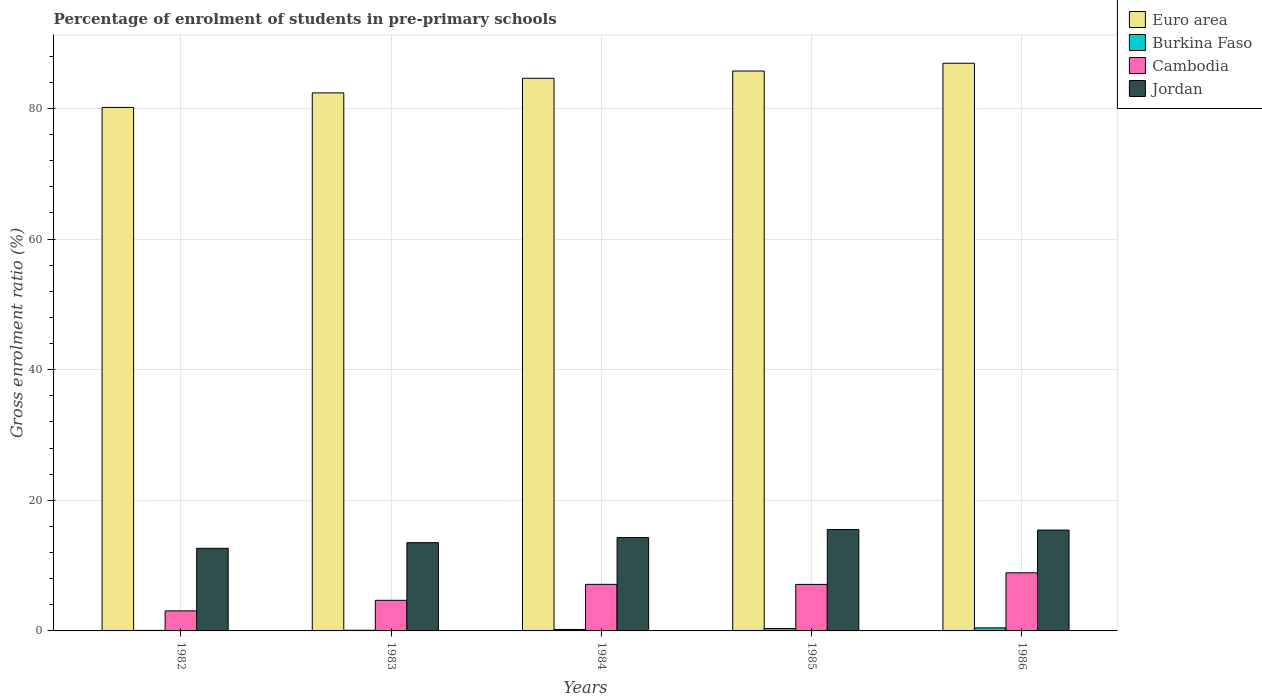Are the number of bars per tick equal to the number of legend labels?
Your answer should be very brief. Yes. How many bars are there on the 2nd tick from the right?
Ensure brevity in your answer.  4. What is the label of the 2nd group of bars from the left?
Offer a terse response. 1983. In how many cases, is the number of bars for a given year not equal to the number of legend labels?
Make the answer very short. 0. What is the percentage of students enrolled in pre-primary schools in Jordan in 1986?
Give a very brief answer. 15.44. Across all years, what is the maximum percentage of students enrolled in pre-primary schools in Cambodia?
Give a very brief answer. 8.9. Across all years, what is the minimum percentage of students enrolled in pre-primary schools in Burkina Faso?
Offer a very short reply. 0.08. In which year was the percentage of students enrolled in pre-primary schools in Cambodia maximum?
Offer a very short reply. 1986. What is the total percentage of students enrolled in pre-primary schools in Cambodia in the graph?
Your response must be concise. 30.91. What is the difference between the percentage of students enrolled in pre-primary schools in Euro area in 1984 and that in 1985?
Your answer should be compact. -1.11. What is the difference between the percentage of students enrolled in pre-primary schools in Euro area in 1986 and the percentage of students enrolled in pre-primary schools in Burkina Faso in 1983?
Give a very brief answer. 86.81. What is the average percentage of students enrolled in pre-primary schools in Euro area per year?
Give a very brief answer. 83.95. In the year 1985, what is the difference between the percentage of students enrolled in pre-primary schools in Burkina Faso and percentage of students enrolled in pre-primary schools in Euro area?
Offer a terse response. -85.36. What is the ratio of the percentage of students enrolled in pre-primary schools in Cambodia in 1983 to that in 1985?
Ensure brevity in your answer.  0.66. Is the difference between the percentage of students enrolled in pre-primary schools in Burkina Faso in 1985 and 1986 greater than the difference between the percentage of students enrolled in pre-primary schools in Euro area in 1985 and 1986?
Provide a short and direct response. Yes. What is the difference between the highest and the second highest percentage of students enrolled in pre-primary schools in Jordan?
Your answer should be very brief. 0.09. What is the difference between the highest and the lowest percentage of students enrolled in pre-primary schools in Euro area?
Offer a very short reply. 6.76. In how many years, is the percentage of students enrolled in pre-primary schools in Burkina Faso greater than the average percentage of students enrolled in pre-primary schools in Burkina Faso taken over all years?
Offer a terse response. 2. Is the sum of the percentage of students enrolled in pre-primary schools in Burkina Faso in 1983 and 1986 greater than the maximum percentage of students enrolled in pre-primary schools in Cambodia across all years?
Offer a very short reply. No. Is it the case that in every year, the sum of the percentage of students enrolled in pre-primary schools in Cambodia and percentage of students enrolled in pre-primary schools in Burkina Faso is greater than the sum of percentage of students enrolled in pre-primary schools in Euro area and percentage of students enrolled in pre-primary schools in Jordan?
Your answer should be compact. No. What does the 2nd bar from the left in 1985 represents?
Your answer should be very brief. Burkina Faso. What does the 4th bar from the right in 1984 represents?
Make the answer very short. Euro area. Is it the case that in every year, the sum of the percentage of students enrolled in pre-primary schools in Jordan and percentage of students enrolled in pre-primary schools in Euro area is greater than the percentage of students enrolled in pre-primary schools in Burkina Faso?
Offer a terse response. Yes. How many bars are there?
Keep it short and to the point. 20. Are the values on the major ticks of Y-axis written in scientific E-notation?
Provide a short and direct response. No. Where does the legend appear in the graph?
Ensure brevity in your answer.  Top right. What is the title of the graph?
Ensure brevity in your answer.  Percentage of enrolment of students in pre-primary schools. Does "North America" appear as one of the legend labels in the graph?
Your answer should be compact. No. What is the label or title of the Y-axis?
Keep it short and to the point. Gross enrolment ratio (%). What is the Gross enrolment ratio (%) in Euro area in 1982?
Offer a very short reply. 80.15. What is the Gross enrolment ratio (%) in Burkina Faso in 1982?
Provide a succinct answer. 0.08. What is the Gross enrolment ratio (%) of Cambodia in 1982?
Your answer should be compact. 3.07. What is the Gross enrolment ratio (%) of Jordan in 1982?
Give a very brief answer. 12.65. What is the Gross enrolment ratio (%) of Euro area in 1983?
Provide a short and direct response. 82.37. What is the Gross enrolment ratio (%) of Burkina Faso in 1983?
Offer a very short reply. 0.1. What is the Gross enrolment ratio (%) in Cambodia in 1983?
Keep it short and to the point. 4.69. What is the Gross enrolment ratio (%) in Jordan in 1983?
Give a very brief answer. 13.51. What is the Gross enrolment ratio (%) of Euro area in 1984?
Provide a succinct answer. 84.61. What is the Gross enrolment ratio (%) of Burkina Faso in 1984?
Give a very brief answer. 0.23. What is the Gross enrolment ratio (%) of Cambodia in 1984?
Offer a very short reply. 7.13. What is the Gross enrolment ratio (%) in Jordan in 1984?
Keep it short and to the point. 14.29. What is the Gross enrolment ratio (%) of Euro area in 1985?
Provide a succinct answer. 85.72. What is the Gross enrolment ratio (%) of Burkina Faso in 1985?
Ensure brevity in your answer.  0.36. What is the Gross enrolment ratio (%) of Cambodia in 1985?
Keep it short and to the point. 7.12. What is the Gross enrolment ratio (%) in Jordan in 1985?
Provide a short and direct response. 15.53. What is the Gross enrolment ratio (%) in Euro area in 1986?
Provide a short and direct response. 86.91. What is the Gross enrolment ratio (%) in Burkina Faso in 1986?
Make the answer very short. 0.46. What is the Gross enrolment ratio (%) of Cambodia in 1986?
Keep it short and to the point. 8.9. What is the Gross enrolment ratio (%) of Jordan in 1986?
Provide a succinct answer. 15.44. Across all years, what is the maximum Gross enrolment ratio (%) in Euro area?
Provide a short and direct response. 86.91. Across all years, what is the maximum Gross enrolment ratio (%) of Burkina Faso?
Your answer should be very brief. 0.46. Across all years, what is the maximum Gross enrolment ratio (%) in Cambodia?
Offer a very short reply. 8.9. Across all years, what is the maximum Gross enrolment ratio (%) in Jordan?
Ensure brevity in your answer.  15.53. Across all years, what is the minimum Gross enrolment ratio (%) of Euro area?
Your answer should be compact. 80.15. Across all years, what is the minimum Gross enrolment ratio (%) in Burkina Faso?
Offer a terse response. 0.08. Across all years, what is the minimum Gross enrolment ratio (%) in Cambodia?
Make the answer very short. 3.07. Across all years, what is the minimum Gross enrolment ratio (%) in Jordan?
Ensure brevity in your answer.  12.65. What is the total Gross enrolment ratio (%) of Euro area in the graph?
Ensure brevity in your answer.  419.77. What is the total Gross enrolment ratio (%) in Burkina Faso in the graph?
Give a very brief answer. 1.24. What is the total Gross enrolment ratio (%) of Cambodia in the graph?
Make the answer very short. 30.91. What is the total Gross enrolment ratio (%) in Jordan in the graph?
Provide a succinct answer. 71.42. What is the difference between the Gross enrolment ratio (%) of Euro area in 1982 and that in 1983?
Ensure brevity in your answer.  -2.23. What is the difference between the Gross enrolment ratio (%) of Burkina Faso in 1982 and that in 1983?
Offer a very short reply. -0.02. What is the difference between the Gross enrolment ratio (%) in Cambodia in 1982 and that in 1983?
Provide a short and direct response. -1.61. What is the difference between the Gross enrolment ratio (%) of Jordan in 1982 and that in 1983?
Offer a very short reply. -0.87. What is the difference between the Gross enrolment ratio (%) in Euro area in 1982 and that in 1984?
Offer a terse response. -4.47. What is the difference between the Gross enrolment ratio (%) of Burkina Faso in 1982 and that in 1984?
Provide a short and direct response. -0.14. What is the difference between the Gross enrolment ratio (%) in Cambodia in 1982 and that in 1984?
Ensure brevity in your answer.  -4.06. What is the difference between the Gross enrolment ratio (%) in Jordan in 1982 and that in 1984?
Offer a terse response. -1.64. What is the difference between the Gross enrolment ratio (%) in Euro area in 1982 and that in 1985?
Make the answer very short. -5.58. What is the difference between the Gross enrolment ratio (%) in Burkina Faso in 1982 and that in 1985?
Give a very brief answer. -0.28. What is the difference between the Gross enrolment ratio (%) in Cambodia in 1982 and that in 1985?
Make the answer very short. -4.05. What is the difference between the Gross enrolment ratio (%) of Jordan in 1982 and that in 1985?
Offer a very short reply. -2.88. What is the difference between the Gross enrolment ratio (%) in Euro area in 1982 and that in 1986?
Provide a short and direct response. -6.76. What is the difference between the Gross enrolment ratio (%) of Burkina Faso in 1982 and that in 1986?
Provide a succinct answer. -0.38. What is the difference between the Gross enrolment ratio (%) in Cambodia in 1982 and that in 1986?
Provide a short and direct response. -5.83. What is the difference between the Gross enrolment ratio (%) of Jordan in 1982 and that in 1986?
Make the answer very short. -2.79. What is the difference between the Gross enrolment ratio (%) in Euro area in 1983 and that in 1984?
Offer a very short reply. -2.24. What is the difference between the Gross enrolment ratio (%) of Burkina Faso in 1983 and that in 1984?
Ensure brevity in your answer.  -0.13. What is the difference between the Gross enrolment ratio (%) in Cambodia in 1983 and that in 1984?
Provide a short and direct response. -2.44. What is the difference between the Gross enrolment ratio (%) of Jordan in 1983 and that in 1984?
Ensure brevity in your answer.  -0.78. What is the difference between the Gross enrolment ratio (%) in Euro area in 1983 and that in 1985?
Make the answer very short. -3.35. What is the difference between the Gross enrolment ratio (%) of Burkina Faso in 1983 and that in 1985?
Give a very brief answer. -0.26. What is the difference between the Gross enrolment ratio (%) of Cambodia in 1983 and that in 1985?
Your answer should be very brief. -2.44. What is the difference between the Gross enrolment ratio (%) of Jordan in 1983 and that in 1985?
Provide a succinct answer. -2.01. What is the difference between the Gross enrolment ratio (%) in Euro area in 1983 and that in 1986?
Your answer should be very brief. -4.54. What is the difference between the Gross enrolment ratio (%) in Burkina Faso in 1983 and that in 1986?
Your answer should be very brief. -0.36. What is the difference between the Gross enrolment ratio (%) in Cambodia in 1983 and that in 1986?
Make the answer very short. -4.21. What is the difference between the Gross enrolment ratio (%) in Jordan in 1983 and that in 1986?
Your answer should be very brief. -1.93. What is the difference between the Gross enrolment ratio (%) of Euro area in 1984 and that in 1985?
Give a very brief answer. -1.11. What is the difference between the Gross enrolment ratio (%) in Burkina Faso in 1984 and that in 1985?
Offer a very short reply. -0.14. What is the difference between the Gross enrolment ratio (%) in Cambodia in 1984 and that in 1985?
Offer a very short reply. 0.01. What is the difference between the Gross enrolment ratio (%) in Jordan in 1984 and that in 1985?
Offer a terse response. -1.24. What is the difference between the Gross enrolment ratio (%) of Euro area in 1984 and that in 1986?
Offer a terse response. -2.3. What is the difference between the Gross enrolment ratio (%) in Burkina Faso in 1984 and that in 1986?
Offer a terse response. -0.24. What is the difference between the Gross enrolment ratio (%) in Cambodia in 1984 and that in 1986?
Your answer should be very brief. -1.77. What is the difference between the Gross enrolment ratio (%) of Jordan in 1984 and that in 1986?
Offer a very short reply. -1.15. What is the difference between the Gross enrolment ratio (%) of Euro area in 1985 and that in 1986?
Your response must be concise. -1.19. What is the difference between the Gross enrolment ratio (%) of Burkina Faso in 1985 and that in 1986?
Provide a succinct answer. -0.1. What is the difference between the Gross enrolment ratio (%) of Cambodia in 1985 and that in 1986?
Keep it short and to the point. -1.78. What is the difference between the Gross enrolment ratio (%) of Jordan in 1985 and that in 1986?
Your response must be concise. 0.09. What is the difference between the Gross enrolment ratio (%) of Euro area in 1982 and the Gross enrolment ratio (%) of Burkina Faso in 1983?
Make the answer very short. 80.05. What is the difference between the Gross enrolment ratio (%) in Euro area in 1982 and the Gross enrolment ratio (%) in Cambodia in 1983?
Make the answer very short. 75.46. What is the difference between the Gross enrolment ratio (%) of Euro area in 1982 and the Gross enrolment ratio (%) of Jordan in 1983?
Offer a terse response. 66.63. What is the difference between the Gross enrolment ratio (%) in Burkina Faso in 1982 and the Gross enrolment ratio (%) in Cambodia in 1983?
Ensure brevity in your answer.  -4.6. What is the difference between the Gross enrolment ratio (%) of Burkina Faso in 1982 and the Gross enrolment ratio (%) of Jordan in 1983?
Your answer should be compact. -13.43. What is the difference between the Gross enrolment ratio (%) in Cambodia in 1982 and the Gross enrolment ratio (%) in Jordan in 1983?
Offer a very short reply. -10.44. What is the difference between the Gross enrolment ratio (%) in Euro area in 1982 and the Gross enrolment ratio (%) in Burkina Faso in 1984?
Offer a terse response. 79.92. What is the difference between the Gross enrolment ratio (%) of Euro area in 1982 and the Gross enrolment ratio (%) of Cambodia in 1984?
Give a very brief answer. 73.02. What is the difference between the Gross enrolment ratio (%) of Euro area in 1982 and the Gross enrolment ratio (%) of Jordan in 1984?
Provide a succinct answer. 65.86. What is the difference between the Gross enrolment ratio (%) of Burkina Faso in 1982 and the Gross enrolment ratio (%) of Cambodia in 1984?
Provide a short and direct response. -7.05. What is the difference between the Gross enrolment ratio (%) in Burkina Faso in 1982 and the Gross enrolment ratio (%) in Jordan in 1984?
Offer a very short reply. -14.21. What is the difference between the Gross enrolment ratio (%) of Cambodia in 1982 and the Gross enrolment ratio (%) of Jordan in 1984?
Your answer should be very brief. -11.22. What is the difference between the Gross enrolment ratio (%) of Euro area in 1982 and the Gross enrolment ratio (%) of Burkina Faso in 1985?
Keep it short and to the point. 79.78. What is the difference between the Gross enrolment ratio (%) in Euro area in 1982 and the Gross enrolment ratio (%) in Cambodia in 1985?
Offer a very short reply. 73.03. What is the difference between the Gross enrolment ratio (%) of Euro area in 1982 and the Gross enrolment ratio (%) of Jordan in 1985?
Your response must be concise. 64.62. What is the difference between the Gross enrolment ratio (%) in Burkina Faso in 1982 and the Gross enrolment ratio (%) in Cambodia in 1985?
Ensure brevity in your answer.  -7.04. What is the difference between the Gross enrolment ratio (%) in Burkina Faso in 1982 and the Gross enrolment ratio (%) in Jordan in 1985?
Provide a short and direct response. -15.44. What is the difference between the Gross enrolment ratio (%) of Cambodia in 1982 and the Gross enrolment ratio (%) of Jordan in 1985?
Make the answer very short. -12.45. What is the difference between the Gross enrolment ratio (%) of Euro area in 1982 and the Gross enrolment ratio (%) of Burkina Faso in 1986?
Your response must be concise. 79.68. What is the difference between the Gross enrolment ratio (%) of Euro area in 1982 and the Gross enrolment ratio (%) of Cambodia in 1986?
Provide a succinct answer. 71.25. What is the difference between the Gross enrolment ratio (%) in Euro area in 1982 and the Gross enrolment ratio (%) in Jordan in 1986?
Your response must be concise. 64.71. What is the difference between the Gross enrolment ratio (%) in Burkina Faso in 1982 and the Gross enrolment ratio (%) in Cambodia in 1986?
Make the answer very short. -8.82. What is the difference between the Gross enrolment ratio (%) in Burkina Faso in 1982 and the Gross enrolment ratio (%) in Jordan in 1986?
Offer a very short reply. -15.36. What is the difference between the Gross enrolment ratio (%) in Cambodia in 1982 and the Gross enrolment ratio (%) in Jordan in 1986?
Your answer should be compact. -12.37. What is the difference between the Gross enrolment ratio (%) in Euro area in 1983 and the Gross enrolment ratio (%) in Burkina Faso in 1984?
Your answer should be very brief. 82.15. What is the difference between the Gross enrolment ratio (%) in Euro area in 1983 and the Gross enrolment ratio (%) in Cambodia in 1984?
Make the answer very short. 75.24. What is the difference between the Gross enrolment ratio (%) of Euro area in 1983 and the Gross enrolment ratio (%) of Jordan in 1984?
Provide a succinct answer. 68.08. What is the difference between the Gross enrolment ratio (%) in Burkina Faso in 1983 and the Gross enrolment ratio (%) in Cambodia in 1984?
Make the answer very short. -7.03. What is the difference between the Gross enrolment ratio (%) of Burkina Faso in 1983 and the Gross enrolment ratio (%) of Jordan in 1984?
Your answer should be compact. -14.19. What is the difference between the Gross enrolment ratio (%) of Cambodia in 1983 and the Gross enrolment ratio (%) of Jordan in 1984?
Keep it short and to the point. -9.6. What is the difference between the Gross enrolment ratio (%) in Euro area in 1983 and the Gross enrolment ratio (%) in Burkina Faso in 1985?
Provide a succinct answer. 82.01. What is the difference between the Gross enrolment ratio (%) of Euro area in 1983 and the Gross enrolment ratio (%) of Cambodia in 1985?
Make the answer very short. 75.25. What is the difference between the Gross enrolment ratio (%) in Euro area in 1983 and the Gross enrolment ratio (%) in Jordan in 1985?
Offer a very short reply. 66.85. What is the difference between the Gross enrolment ratio (%) in Burkina Faso in 1983 and the Gross enrolment ratio (%) in Cambodia in 1985?
Offer a very short reply. -7.02. What is the difference between the Gross enrolment ratio (%) of Burkina Faso in 1983 and the Gross enrolment ratio (%) of Jordan in 1985?
Keep it short and to the point. -15.43. What is the difference between the Gross enrolment ratio (%) of Cambodia in 1983 and the Gross enrolment ratio (%) of Jordan in 1985?
Provide a succinct answer. -10.84. What is the difference between the Gross enrolment ratio (%) of Euro area in 1983 and the Gross enrolment ratio (%) of Burkina Faso in 1986?
Give a very brief answer. 81.91. What is the difference between the Gross enrolment ratio (%) in Euro area in 1983 and the Gross enrolment ratio (%) in Cambodia in 1986?
Offer a terse response. 73.48. What is the difference between the Gross enrolment ratio (%) in Euro area in 1983 and the Gross enrolment ratio (%) in Jordan in 1986?
Provide a succinct answer. 66.93. What is the difference between the Gross enrolment ratio (%) of Burkina Faso in 1983 and the Gross enrolment ratio (%) of Cambodia in 1986?
Provide a short and direct response. -8.8. What is the difference between the Gross enrolment ratio (%) of Burkina Faso in 1983 and the Gross enrolment ratio (%) of Jordan in 1986?
Your response must be concise. -15.34. What is the difference between the Gross enrolment ratio (%) of Cambodia in 1983 and the Gross enrolment ratio (%) of Jordan in 1986?
Provide a succinct answer. -10.75. What is the difference between the Gross enrolment ratio (%) in Euro area in 1984 and the Gross enrolment ratio (%) in Burkina Faso in 1985?
Your response must be concise. 84.25. What is the difference between the Gross enrolment ratio (%) in Euro area in 1984 and the Gross enrolment ratio (%) in Cambodia in 1985?
Provide a succinct answer. 77.49. What is the difference between the Gross enrolment ratio (%) of Euro area in 1984 and the Gross enrolment ratio (%) of Jordan in 1985?
Your answer should be compact. 69.09. What is the difference between the Gross enrolment ratio (%) in Burkina Faso in 1984 and the Gross enrolment ratio (%) in Cambodia in 1985?
Provide a succinct answer. -6.89. What is the difference between the Gross enrolment ratio (%) in Burkina Faso in 1984 and the Gross enrolment ratio (%) in Jordan in 1985?
Provide a short and direct response. -15.3. What is the difference between the Gross enrolment ratio (%) in Cambodia in 1984 and the Gross enrolment ratio (%) in Jordan in 1985?
Offer a very short reply. -8.4. What is the difference between the Gross enrolment ratio (%) of Euro area in 1984 and the Gross enrolment ratio (%) of Burkina Faso in 1986?
Make the answer very short. 84.15. What is the difference between the Gross enrolment ratio (%) of Euro area in 1984 and the Gross enrolment ratio (%) of Cambodia in 1986?
Keep it short and to the point. 75.71. What is the difference between the Gross enrolment ratio (%) of Euro area in 1984 and the Gross enrolment ratio (%) of Jordan in 1986?
Make the answer very short. 69.17. What is the difference between the Gross enrolment ratio (%) of Burkina Faso in 1984 and the Gross enrolment ratio (%) of Cambodia in 1986?
Your answer should be compact. -8.67. What is the difference between the Gross enrolment ratio (%) of Burkina Faso in 1984 and the Gross enrolment ratio (%) of Jordan in 1986?
Make the answer very short. -15.21. What is the difference between the Gross enrolment ratio (%) of Cambodia in 1984 and the Gross enrolment ratio (%) of Jordan in 1986?
Your response must be concise. -8.31. What is the difference between the Gross enrolment ratio (%) in Euro area in 1985 and the Gross enrolment ratio (%) in Burkina Faso in 1986?
Your answer should be very brief. 85.26. What is the difference between the Gross enrolment ratio (%) in Euro area in 1985 and the Gross enrolment ratio (%) in Cambodia in 1986?
Provide a short and direct response. 76.82. What is the difference between the Gross enrolment ratio (%) of Euro area in 1985 and the Gross enrolment ratio (%) of Jordan in 1986?
Make the answer very short. 70.28. What is the difference between the Gross enrolment ratio (%) in Burkina Faso in 1985 and the Gross enrolment ratio (%) in Cambodia in 1986?
Give a very brief answer. -8.53. What is the difference between the Gross enrolment ratio (%) in Burkina Faso in 1985 and the Gross enrolment ratio (%) in Jordan in 1986?
Your response must be concise. -15.08. What is the difference between the Gross enrolment ratio (%) of Cambodia in 1985 and the Gross enrolment ratio (%) of Jordan in 1986?
Your response must be concise. -8.32. What is the average Gross enrolment ratio (%) of Euro area per year?
Your answer should be very brief. 83.95. What is the average Gross enrolment ratio (%) of Burkina Faso per year?
Provide a succinct answer. 0.25. What is the average Gross enrolment ratio (%) of Cambodia per year?
Your response must be concise. 6.18. What is the average Gross enrolment ratio (%) in Jordan per year?
Keep it short and to the point. 14.28. In the year 1982, what is the difference between the Gross enrolment ratio (%) in Euro area and Gross enrolment ratio (%) in Burkina Faso?
Ensure brevity in your answer.  80.07. In the year 1982, what is the difference between the Gross enrolment ratio (%) of Euro area and Gross enrolment ratio (%) of Cambodia?
Your answer should be very brief. 77.08. In the year 1982, what is the difference between the Gross enrolment ratio (%) of Euro area and Gross enrolment ratio (%) of Jordan?
Offer a terse response. 67.5. In the year 1982, what is the difference between the Gross enrolment ratio (%) of Burkina Faso and Gross enrolment ratio (%) of Cambodia?
Your answer should be very brief. -2.99. In the year 1982, what is the difference between the Gross enrolment ratio (%) of Burkina Faso and Gross enrolment ratio (%) of Jordan?
Make the answer very short. -12.57. In the year 1982, what is the difference between the Gross enrolment ratio (%) in Cambodia and Gross enrolment ratio (%) in Jordan?
Keep it short and to the point. -9.58. In the year 1983, what is the difference between the Gross enrolment ratio (%) of Euro area and Gross enrolment ratio (%) of Burkina Faso?
Provide a succinct answer. 82.27. In the year 1983, what is the difference between the Gross enrolment ratio (%) in Euro area and Gross enrolment ratio (%) in Cambodia?
Offer a very short reply. 77.69. In the year 1983, what is the difference between the Gross enrolment ratio (%) of Euro area and Gross enrolment ratio (%) of Jordan?
Offer a very short reply. 68.86. In the year 1983, what is the difference between the Gross enrolment ratio (%) of Burkina Faso and Gross enrolment ratio (%) of Cambodia?
Make the answer very short. -4.59. In the year 1983, what is the difference between the Gross enrolment ratio (%) of Burkina Faso and Gross enrolment ratio (%) of Jordan?
Provide a short and direct response. -13.41. In the year 1983, what is the difference between the Gross enrolment ratio (%) of Cambodia and Gross enrolment ratio (%) of Jordan?
Provide a succinct answer. -8.83. In the year 1984, what is the difference between the Gross enrolment ratio (%) in Euro area and Gross enrolment ratio (%) in Burkina Faso?
Provide a succinct answer. 84.39. In the year 1984, what is the difference between the Gross enrolment ratio (%) of Euro area and Gross enrolment ratio (%) of Cambodia?
Offer a terse response. 77.48. In the year 1984, what is the difference between the Gross enrolment ratio (%) of Euro area and Gross enrolment ratio (%) of Jordan?
Your answer should be compact. 70.32. In the year 1984, what is the difference between the Gross enrolment ratio (%) of Burkina Faso and Gross enrolment ratio (%) of Cambodia?
Offer a very short reply. -6.9. In the year 1984, what is the difference between the Gross enrolment ratio (%) in Burkina Faso and Gross enrolment ratio (%) in Jordan?
Offer a very short reply. -14.06. In the year 1984, what is the difference between the Gross enrolment ratio (%) of Cambodia and Gross enrolment ratio (%) of Jordan?
Your answer should be very brief. -7.16. In the year 1985, what is the difference between the Gross enrolment ratio (%) in Euro area and Gross enrolment ratio (%) in Burkina Faso?
Provide a succinct answer. 85.36. In the year 1985, what is the difference between the Gross enrolment ratio (%) in Euro area and Gross enrolment ratio (%) in Cambodia?
Give a very brief answer. 78.6. In the year 1985, what is the difference between the Gross enrolment ratio (%) in Euro area and Gross enrolment ratio (%) in Jordan?
Offer a terse response. 70.2. In the year 1985, what is the difference between the Gross enrolment ratio (%) in Burkina Faso and Gross enrolment ratio (%) in Cambodia?
Provide a succinct answer. -6.76. In the year 1985, what is the difference between the Gross enrolment ratio (%) of Burkina Faso and Gross enrolment ratio (%) of Jordan?
Your answer should be very brief. -15.16. In the year 1985, what is the difference between the Gross enrolment ratio (%) of Cambodia and Gross enrolment ratio (%) of Jordan?
Ensure brevity in your answer.  -8.4. In the year 1986, what is the difference between the Gross enrolment ratio (%) in Euro area and Gross enrolment ratio (%) in Burkina Faso?
Your answer should be very brief. 86.44. In the year 1986, what is the difference between the Gross enrolment ratio (%) of Euro area and Gross enrolment ratio (%) of Cambodia?
Your answer should be very brief. 78.01. In the year 1986, what is the difference between the Gross enrolment ratio (%) in Euro area and Gross enrolment ratio (%) in Jordan?
Provide a short and direct response. 71.47. In the year 1986, what is the difference between the Gross enrolment ratio (%) in Burkina Faso and Gross enrolment ratio (%) in Cambodia?
Offer a terse response. -8.43. In the year 1986, what is the difference between the Gross enrolment ratio (%) in Burkina Faso and Gross enrolment ratio (%) in Jordan?
Keep it short and to the point. -14.98. In the year 1986, what is the difference between the Gross enrolment ratio (%) of Cambodia and Gross enrolment ratio (%) of Jordan?
Your answer should be very brief. -6.54. What is the ratio of the Gross enrolment ratio (%) in Burkina Faso in 1982 to that in 1983?
Give a very brief answer. 0.83. What is the ratio of the Gross enrolment ratio (%) of Cambodia in 1982 to that in 1983?
Your response must be concise. 0.66. What is the ratio of the Gross enrolment ratio (%) in Jordan in 1982 to that in 1983?
Offer a very short reply. 0.94. What is the ratio of the Gross enrolment ratio (%) in Euro area in 1982 to that in 1984?
Give a very brief answer. 0.95. What is the ratio of the Gross enrolment ratio (%) in Burkina Faso in 1982 to that in 1984?
Your answer should be very brief. 0.36. What is the ratio of the Gross enrolment ratio (%) of Cambodia in 1982 to that in 1984?
Your answer should be very brief. 0.43. What is the ratio of the Gross enrolment ratio (%) of Jordan in 1982 to that in 1984?
Provide a succinct answer. 0.89. What is the ratio of the Gross enrolment ratio (%) in Euro area in 1982 to that in 1985?
Keep it short and to the point. 0.94. What is the ratio of the Gross enrolment ratio (%) of Burkina Faso in 1982 to that in 1985?
Give a very brief answer. 0.23. What is the ratio of the Gross enrolment ratio (%) in Cambodia in 1982 to that in 1985?
Ensure brevity in your answer.  0.43. What is the ratio of the Gross enrolment ratio (%) of Jordan in 1982 to that in 1985?
Your answer should be very brief. 0.81. What is the ratio of the Gross enrolment ratio (%) of Euro area in 1982 to that in 1986?
Make the answer very short. 0.92. What is the ratio of the Gross enrolment ratio (%) of Burkina Faso in 1982 to that in 1986?
Your answer should be very brief. 0.18. What is the ratio of the Gross enrolment ratio (%) of Cambodia in 1982 to that in 1986?
Your answer should be compact. 0.35. What is the ratio of the Gross enrolment ratio (%) of Jordan in 1982 to that in 1986?
Provide a short and direct response. 0.82. What is the ratio of the Gross enrolment ratio (%) of Euro area in 1983 to that in 1984?
Your answer should be compact. 0.97. What is the ratio of the Gross enrolment ratio (%) in Burkina Faso in 1983 to that in 1984?
Keep it short and to the point. 0.44. What is the ratio of the Gross enrolment ratio (%) of Cambodia in 1983 to that in 1984?
Give a very brief answer. 0.66. What is the ratio of the Gross enrolment ratio (%) of Jordan in 1983 to that in 1984?
Offer a terse response. 0.95. What is the ratio of the Gross enrolment ratio (%) of Euro area in 1983 to that in 1985?
Offer a terse response. 0.96. What is the ratio of the Gross enrolment ratio (%) of Burkina Faso in 1983 to that in 1985?
Keep it short and to the point. 0.27. What is the ratio of the Gross enrolment ratio (%) of Cambodia in 1983 to that in 1985?
Provide a short and direct response. 0.66. What is the ratio of the Gross enrolment ratio (%) in Jordan in 1983 to that in 1985?
Give a very brief answer. 0.87. What is the ratio of the Gross enrolment ratio (%) of Euro area in 1983 to that in 1986?
Offer a terse response. 0.95. What is the ratio of the Gross enrolment ratio (%) of Burkina Faso in 1983 to that in 1986?
Make the answer very short. 0.21. What is the ratio of the Gross enrolment ratio (%) of Cambodia in 1983 to that in 1986?
Give a very brief answer. 0.53. What is the ratio of the Gross enrolment ratio (%) of Jordan in 1983 to that in 1986?
Your response must be concise. 0.88. What is the ratio of the Gross enrolment ratio (%) of Euro area in 1984 to that in 1985?
Give a very brief answer. 0.99. What is the ratio of the Gross enrolment ratio (%) of Burkina Faso in 1984 to that in 1985?
Make the answer very short. 0.62. What is the ratio of the Gross enrolment ratio (%) in Jordan in 1984 to that in 1985?
Ensure brevity in your answer.  0.92. What is the ratio of the Gross enrolment ratio (%) in Euro area in 1984 to that in 1986?
Provide a succinct answer. 0.97. What is the ratio of the Gross enrolment ratio (%) in Burkina Faso in 1984 to that in 1986?
Provide a succinct answer. 0.49. What is the ratio of the Gross enrolment ratio (%) in Cambodia in 1984 to that in 1986?
Keep it short and to the point. 0.8. What is the ratio of the Gross enrolment ratio (%) of Jordan in 1984 to that in 1986?
Ensure brevity in your answer.  0.93. What is the ratio of the Gross enrolment ratio (%) in Euro area in 1985 to that in 1986?
Make the answer very short. 0.99. What is the ratio of the Gross enrolment ratio (%) of Burkina Faso in 1985 to that in 1986?
Ensure brevity in your answer.  0.78. What is the ratio of the Gross enrolment ratio (%) in Cambodia in 1985 to that in 1986?
Offer a terse response. 0.8. What is the ratio of the Gross enrolment ratio (%) in Jordan in 1985 to that in 1986?
Offer a very short reply. 1.01. What is the difference between the highest and the second highest Gross enrolment ratio (%) in Euro area?
Your answer should be compact. 1.19. What is the difference between the highest and the second highest Gross enrolment ratio (%) in Burkina Faso?
Your answer should be compact. 0.1. What is the difference between the highest and the second highest Gross enrolment ratio (%) of Cambodia?
Your response must be concise. 1.77. What is the difference between the highest and the second highest Gross enrolment ratio (%) of Jordan?
Ensure brevity in your answer.  0.09. What is the difference between the highest and the lowest Gross enrolment ratio (%) of Euro area?
Keep it short and to the point. 6.76. What is the difference between the highest and the lowest Gross enrolment ratio (%) in Burkina Faso?
Your answer should be very brief. 0.38. What is the difference between the highest and the lowest Gross enrolment ratio (%) in Cambodia?
Ensure brevity in your answer.  5.83. What is the difference between the highest and the lowest Gross enrolment ratio (%) of Jordan?
Offer a terse response. 2.88. 